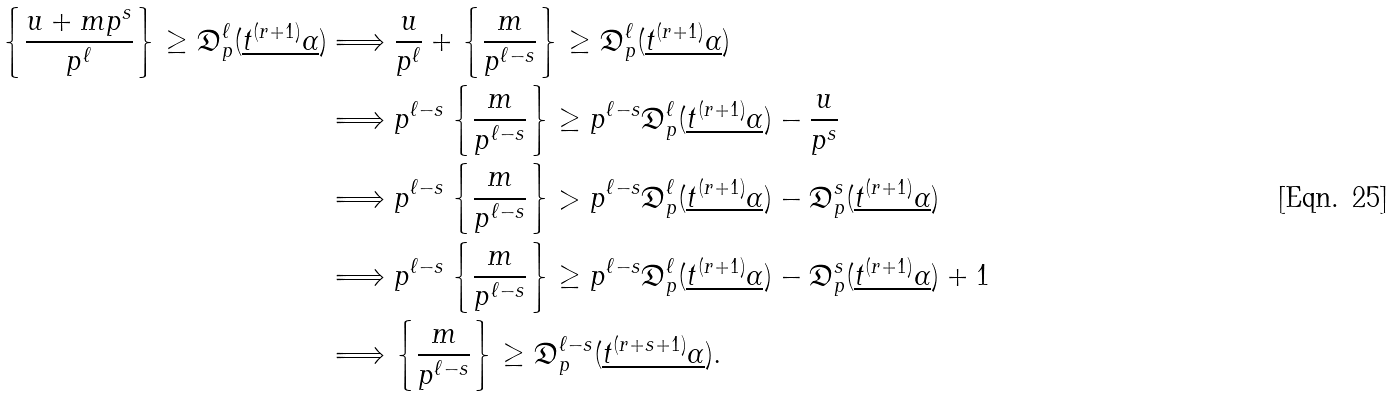Convert formula to latex. <formula><loc_0><loc_0><loc_500><loc_500>\left \{ \frac { u + m p ^ { s } } { p ^ { \ell } } \right \} \geq \mathfrak { D } _ { p } ^ { \ell } ( \underline { t ^ { ( r + 1 ) } \alpha } ) & \Longrightarrow \frac { u } { p ^ { \ell } } + \left \{ \frac { m } { p ^ { \ell - s } } \right \} \geq \mathfrak { D } _ { p } ^ { \ell } ( \underline { t ^ { ( r + 1 ) } \alpha } ) \\ & \Longrightarrow p ^ { \ell - s } \left \{ \frac { m } { p ^ { \ell - s } } \right \} \geq p ^ { \ell - s } \mathfrak { D } _ { p } ^ { \ell } ( \underline { t ^ { ( r + 1 ) } \alpha } ) - \frac { u } { p ^ { s } } \\ & \Longrightarrow p ^ { \ell - s } \left \{ \frac { m } { p ^ { \ell - s } } \right \} > p ^ { \ell - s } \mathfrak { D } _ { p } ^ { \ell } ( \underline { t ^ { ( r + 1 ) } \alpha } ) - \mathfrak { D } _ { p } ^ { s } ( \underline { t ^ { ( r + 1 ) } \alpha } ) \\ & \Longrightarrow p ^ { \ell - s } \left \{ \frac { m } { p ^ { \ell - s } } \right \} \geq p ^ { \ell - s } \mathfrak { D } _ { p } ^ { \ell } ( \underline { t ^ { ( r + 1 ) } \alpha } ) - \mathfrak { D } _ { p } ^ { s } ( \underline { t ^ { ( r + 1 ) } \alpha } ) + 1 \\ & \Longrightarrow \left \{ \frac { m } { p ^ { \ell - s } } \right \} \geq \mathfrak { D } _ { p } ^ { \ell - s } ( \underline { t ^ { ( r + s + 1 ) } \alpha } ) .</formula> 